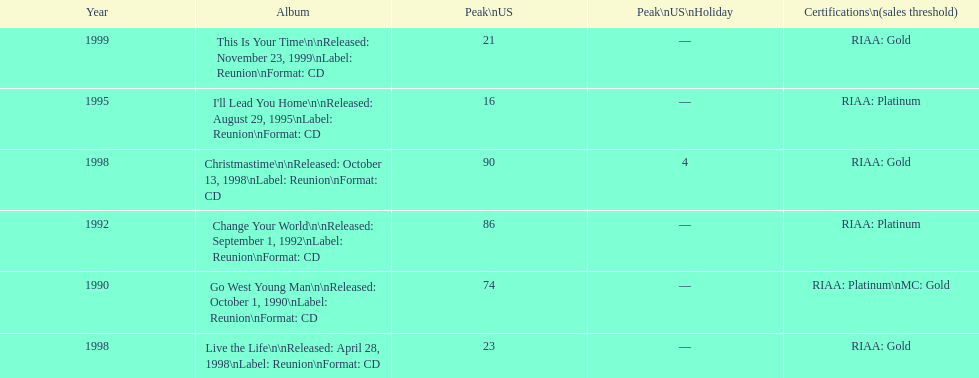Which album has the least peak in the us? I'll Lead You Home. 